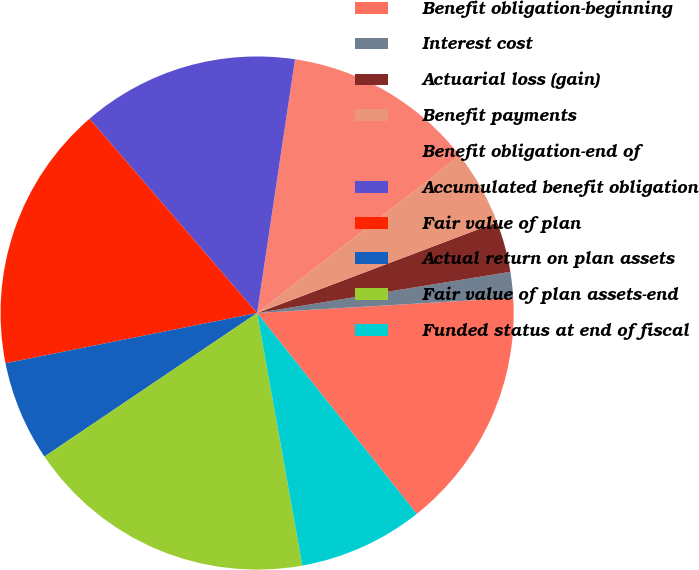<chart> <loc_0><loc_0><loc_500><loc_500><pie_chart><fcel>Benefit obligation-beginning<fcel>Interest cost<fcel>Actuarial loss (gain)<fcel>Benefit payments<fcel>Benefit obligation-end of<fcel>Accumulated benefit obligation<fcel>Fair value of plan<fcel>Actual return on plan assets<fcel>Fair value of plan assets-end<fcel>Funded status at end of fiscal<nl><fcel>15.25%<fcel>1.63%<fcel>3.19%<fcel>4.75%<fcel>12.13%<fcel>13.69%<fcel>16.81%<fcel>6.31%<fcel>18.37%<fcel>7.87%<nl></chart> 